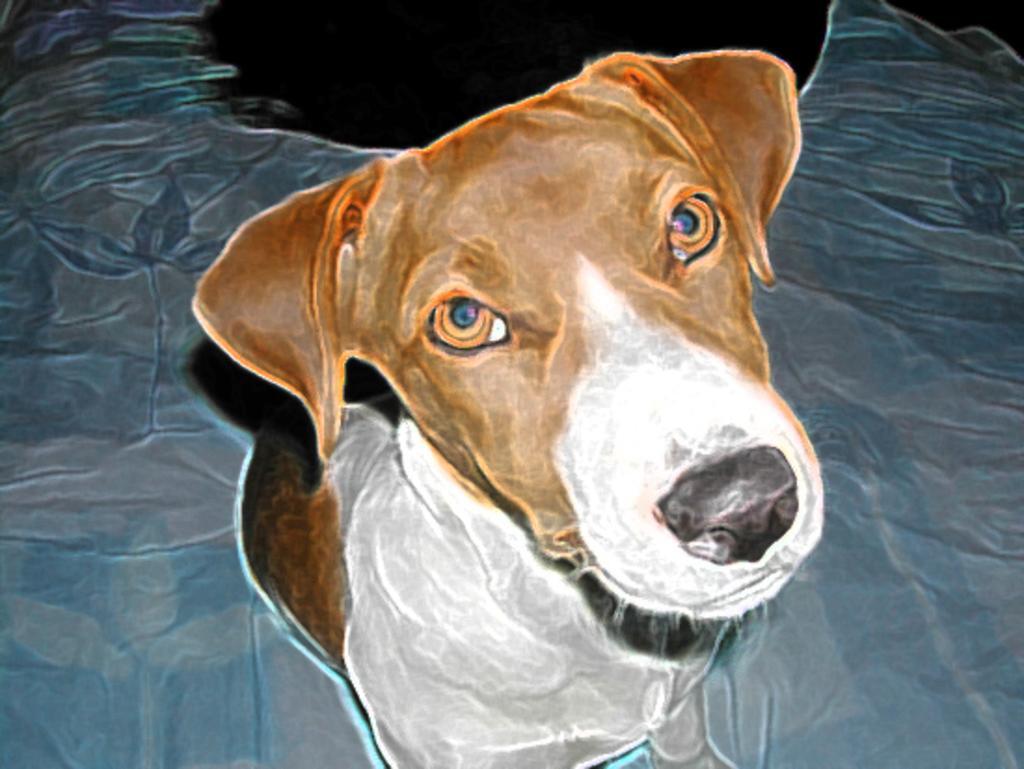In one or two sentences, can you explain what this image depicts? In this image we can see painting of a dog. 